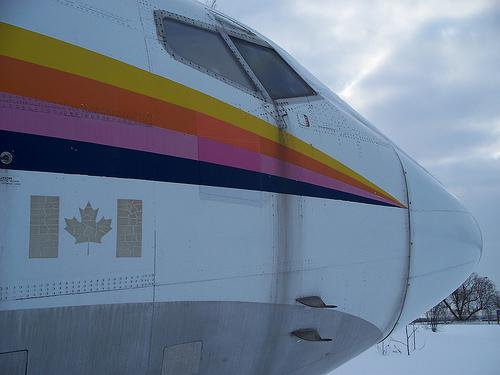Question: what color are the clouds?
Choices:
A. Black.
B. White.
C. Grey.
D. Pink.
Answer with the letter. Answer: C Question: how is the sky?
Choices:
A. Bright and sunny.
B. Filled with clouds.
C. Filled with stars.
D. Jet black.
Answer with the letter. Answer: B 